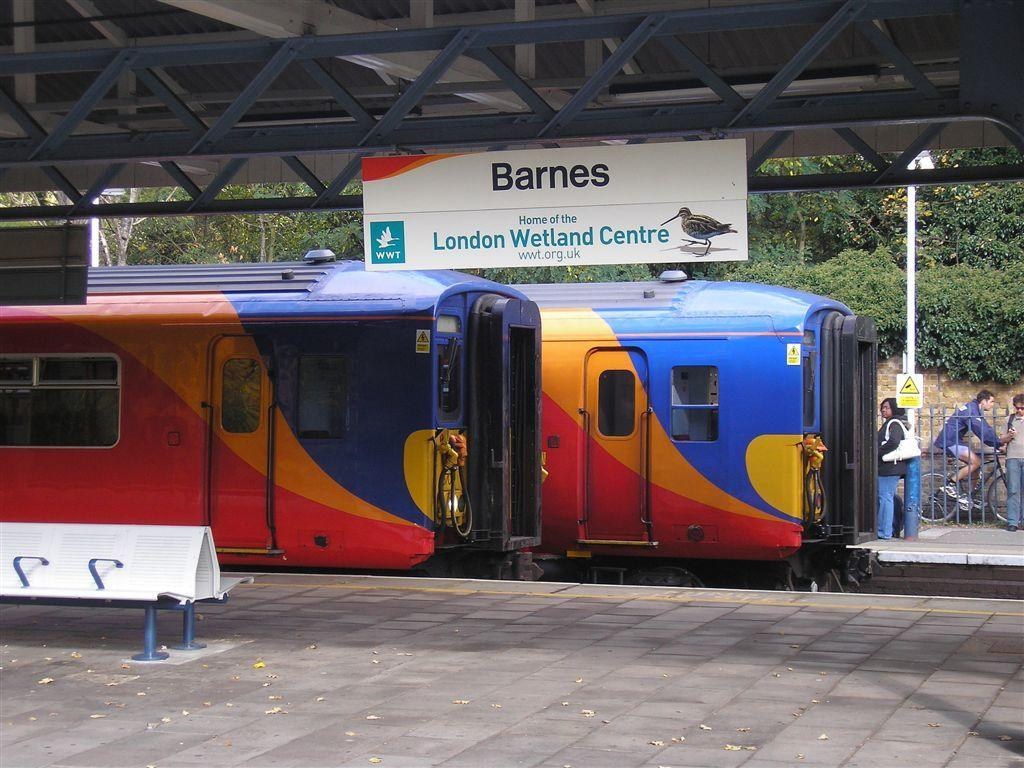<image>
Share a concise interpretation of the image provided. A colorful train is at the Barnes station. 